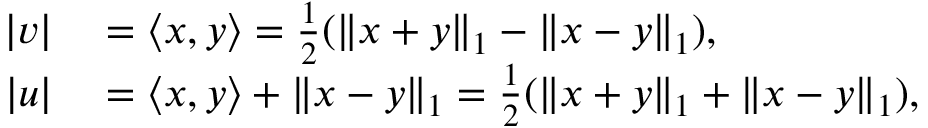<formula> <loc_0><loc_0><loc_500><loc_500>\begin{array} { r l } { | v | } & = \langle x , y \rangle = \frac { 1 } { 2 } ( \| x + y \| _ { 1 } - \| x - y \| _ { 1 } ) , } \\ { | u | } & = \langle x , y \rangle + \| x - y \| _ { 1 } = \frac { 1 } { 2 } ( \| x + y \| _ { 1 } + \| x - y \| _ { 1 } ) , } \end{array}</formula> 